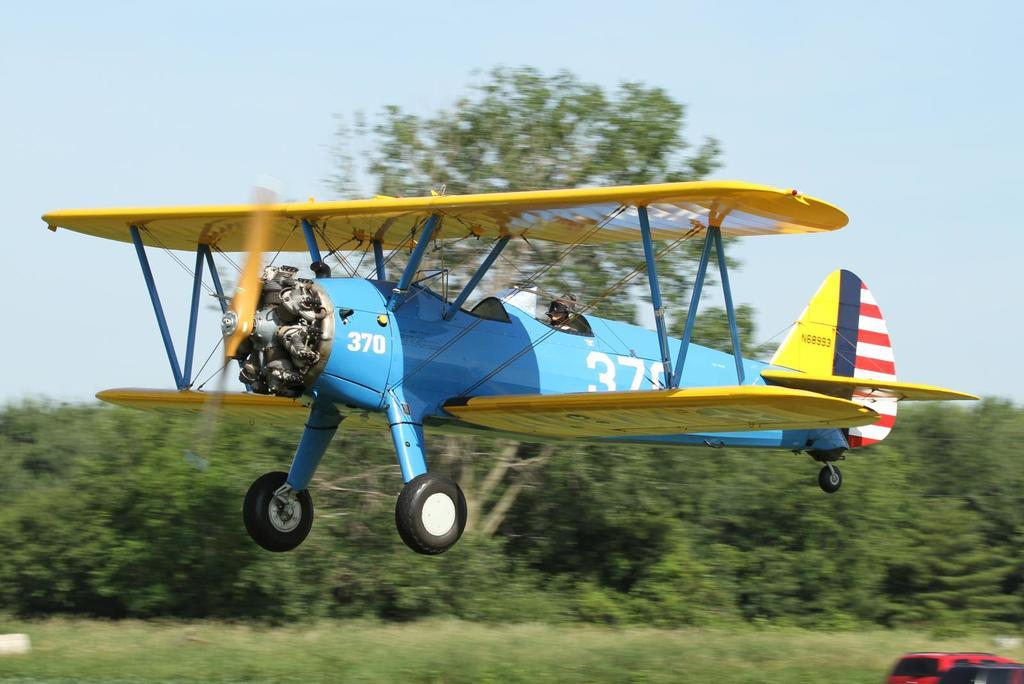<image>
Describe the image concisely. A blue and yellow propeller plane with number 370 is flying 